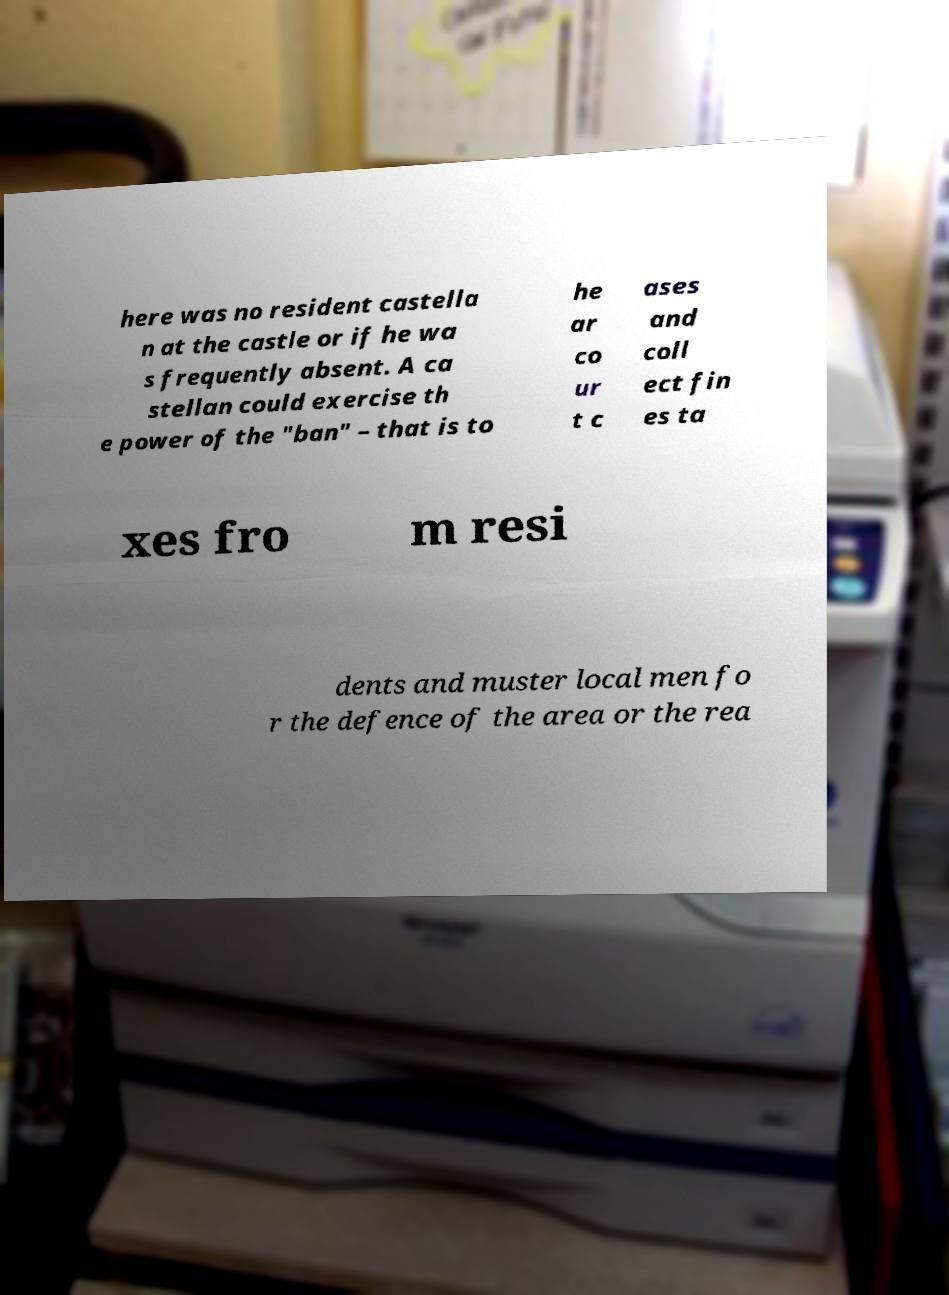Please identify and transcribe the text found in this image. here was no resident castella n at the castle or if he wa s frequently absent. A ca stellan could exercise th e power of the "ban" – that is to he ar co ur t c ases and coll ect fin es ta xes fro m resi dents and muster local men fo r the defence of the area or the rea 